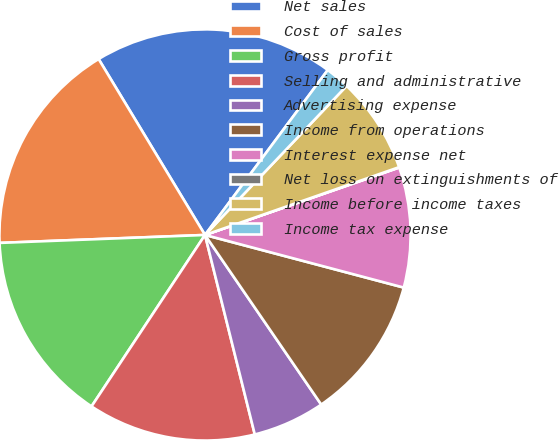Convert chart. <chart><loc_0><loc_0><loc_500><loc_500><pie_chart><fcel>Net sales<fcel>Cost of sales<fcel>Gross profit<fcel>Selling and administrative<fcel>Advertising expense<fcel>Income from operations<fcel>Interest expense net<fcel>Net loss on extinguishments of<fcel>Income before income taxes<fcel>Income tax expense<nl><fcel>18.84%<fcel>16.96%<fcel>15.08%<fcel>13.2%<fcel>5.67%<fcel>11.32%<fcel>9.44%<fcel>0.03%<fcel>7.56%<fcel>1.91%<nl></chart> 